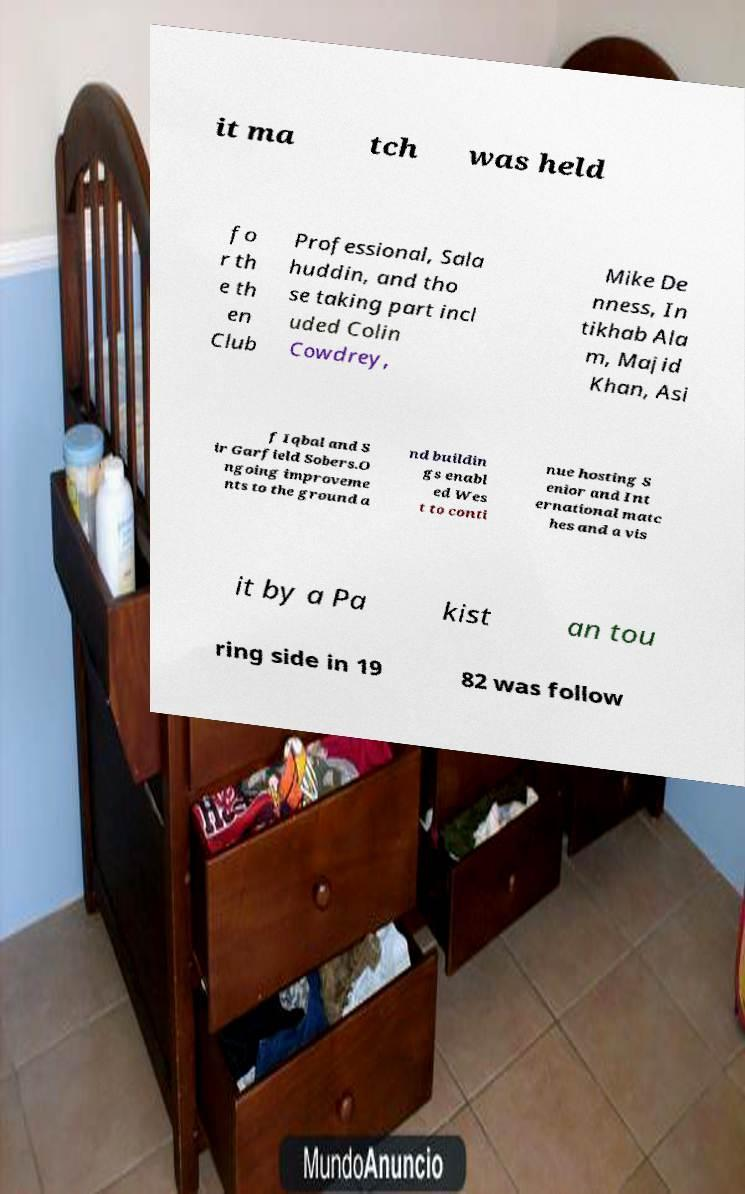What messages or text are displayed in this image? I need them in a readable, typed format. it ma tch was held fo r th e th en Club Professional, Sala huddin, and tho se taking part incl uded Colin Cowdrey, Mike De nness, In tikhab Ala m, Majid Khan, Asi f Iqbal and S ir Garfield Sobers.O ngoing improveme nts to the ground a nd buildin gs enabl ed Wes t to conti nue hosting S enior and Int ernational matc hes and a vis it by a Pa kist an tou ring side in 19 82 was follow 